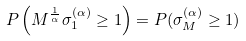<formula> <loc_0><loc_0><loc_500><loc_500>P \left ( M ^ { \frac { 1 } { \alpha } } \sigma _ { 1 } ^ { ( \alpha ) } \geq 1 \right ) = P ( \sigma _ { M } ^ { ( \alpha ) } \geq 1 )</formula> 